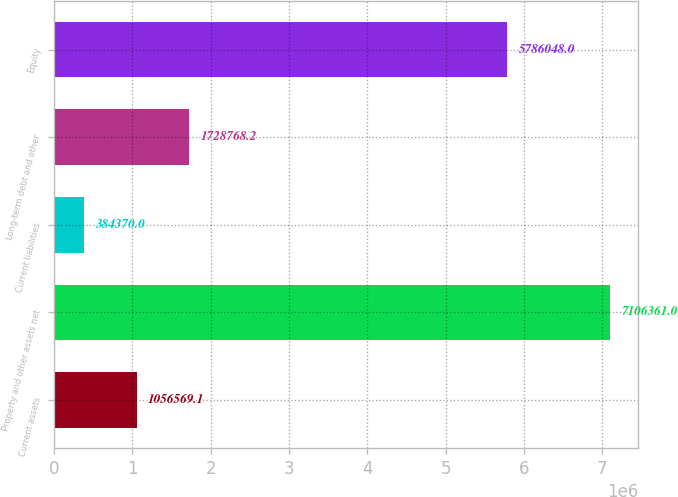Convert chart. <chart><loc_0><loc_0><loc_500><loc_500><bar_chart><fcel>Current assets<fcel>Property and other assets net<fcel>Current liabilities<fcel>Long-term debt and other<fcel>Equity<nl><fcel>1.05657e+06<fcel>7.10636e+06<fcel>384370<fcel>1.72877e+06<fcel>5.78605e+06<nl></chart> 